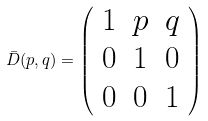<formula> <loc_0><loc_0><loc_500><loc_500>\bar { D } ( p , q ) = \left ( \begin{array} { c c c } 1 & p & q \\ 0 & 1 & 0 \\ 0 & 0 & 1 \\ \end{array} \right )</formula> 